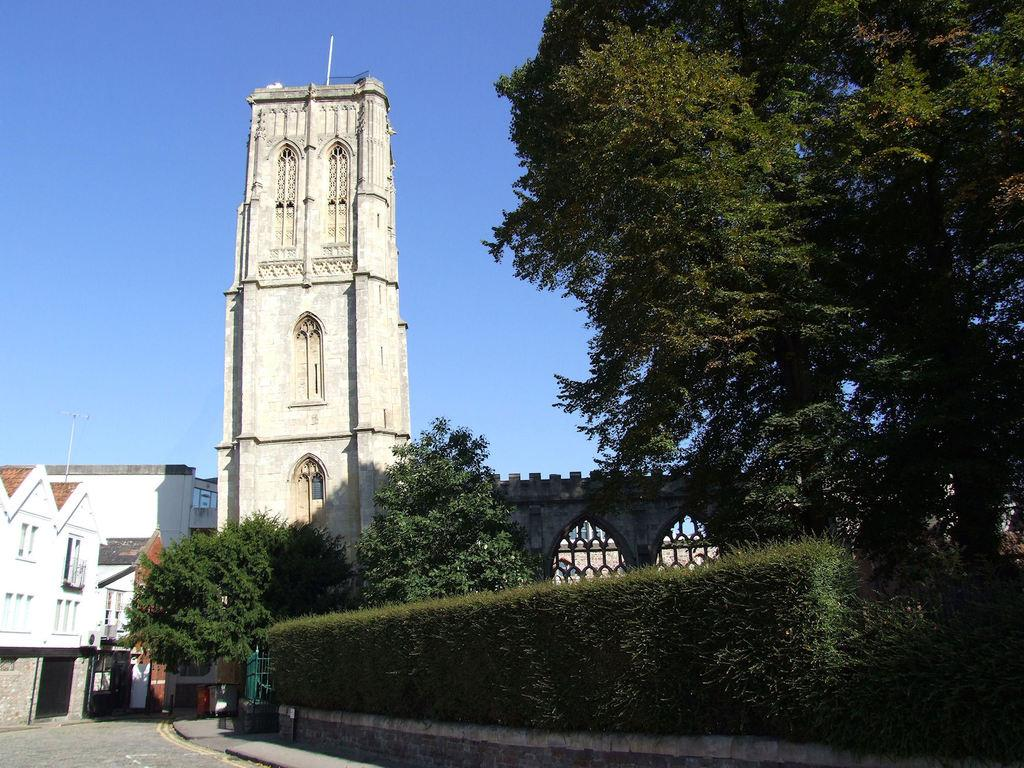What type of structures can be seen in the image? There are buildings in the image. What type of vegetation is present in the image? There are trees and shrubs in the image. What is the tallest structure in the image? There is a tower in the image. What is visible at the top of the image? The sky is visible at the top of the image. What is visible at the bottom of the image? There is a road visible at the bottom of the image. What shape is the hope depicted in the image? There is no depiction of hope in the image; it features buildings, trees, shrubs, a tower, the sky, and a road. What type of pest can be seen crawling on the tower in the image? There are no pests visible in the image, and the tower is not being crawled upon. 